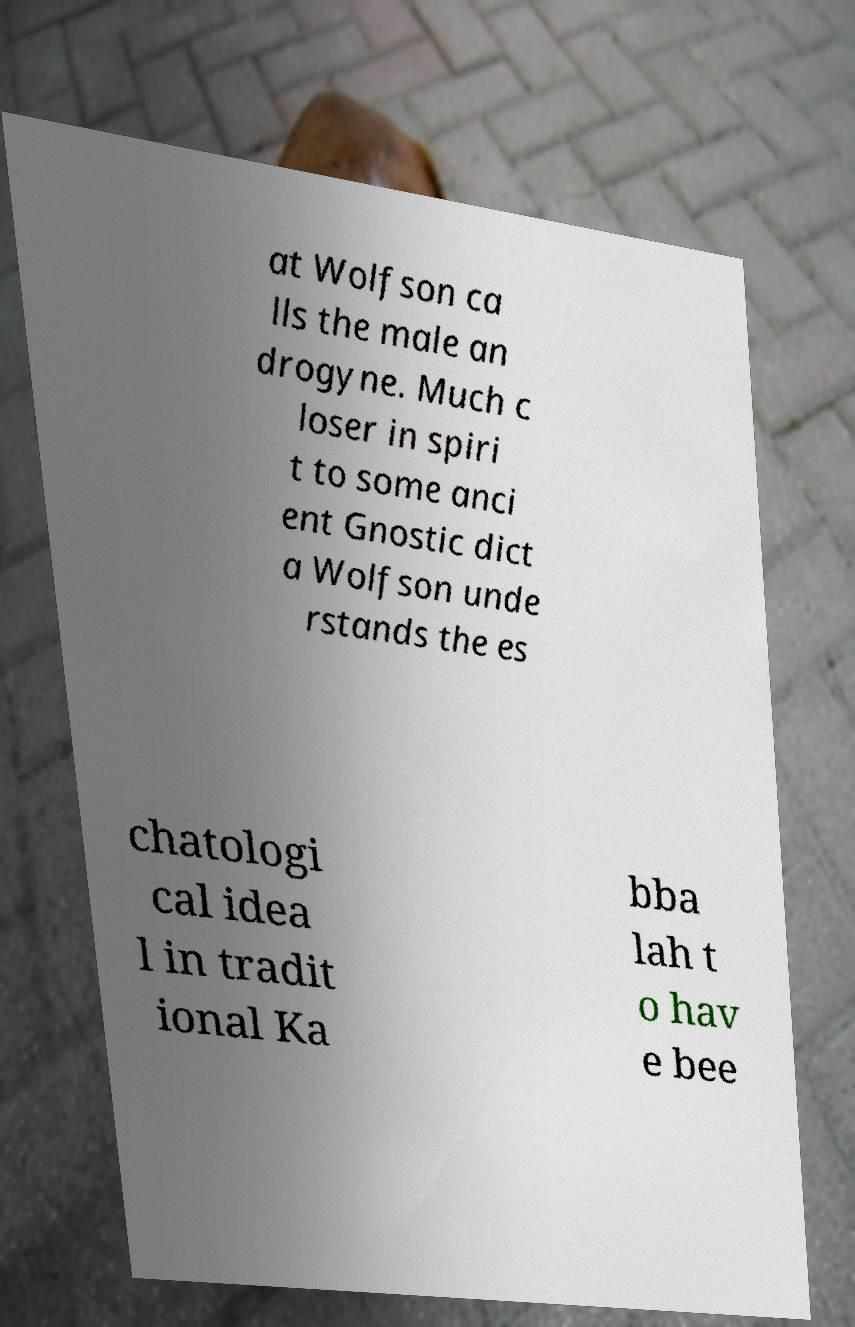There's text embedded in this image that I need extracted. Can you transcribe it verbatim? at Wolfson ca lls the male an drogyne. Much c loser in spiri t to some anci ent Gnostic dict a Wolfson unde rstands the es chatologi cal idea l in tradit ional Ka bba lah t o hav e bee 